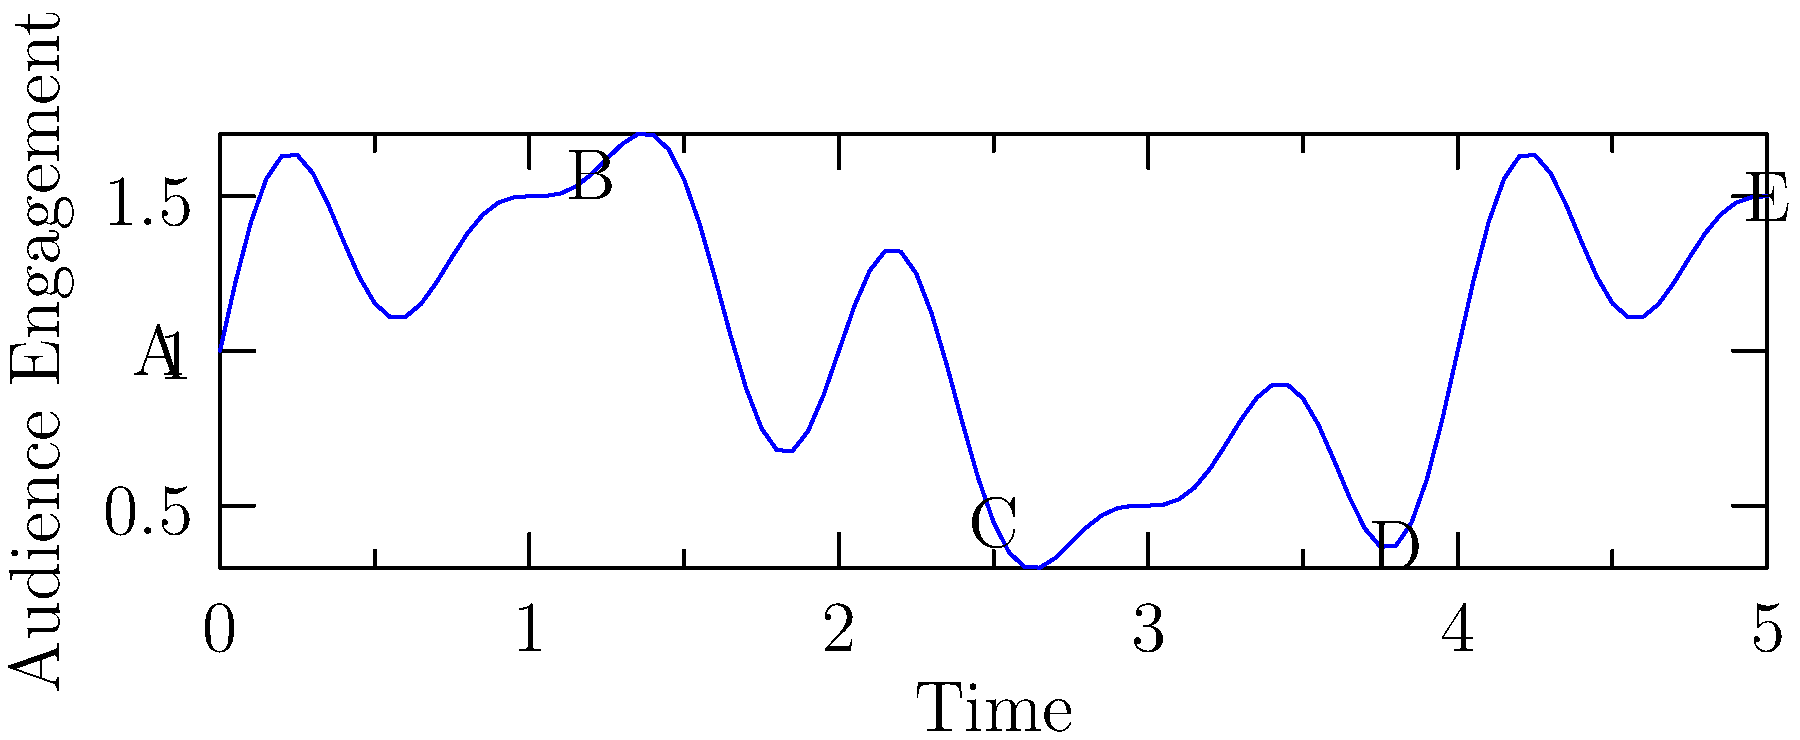In the story arc progression shown above, which point represents the climax that would likely resonate most strongly with both religious and secular audiences in a film that appeals to both demographics? To determine the climax that would resonate with both religious and secular audiences, we need to analyze the story arc progression:

1. Point A: This represents the beginning of the story, typically setting up the characters and conflict.

2. Point B: This is the first significant peak, possibly representing an early challenge or revelation that engages both audiences.

3. Point C: This is the highest peak in the graph, indicating the most intense moment of audience engagement. This would likely be the climax of the film, where:
   - For religious audiences: It might represent a moment of profound spiritual significance or divine intervention.
   - For secular audiences: It could be the resolution of the main conflict or a moment of human triumph.

4. Point D: This is a secondary peak, possibly representing a resolution or aftermath that ties together themes for both audience types.

5. Point E: This is the endpoint of the story, likely providing closure for all viewers.

Given that Point C is the highest peak and occurs at a central point in the story, it is the most likely to represent the climax that would resonate strongly with both religious and secular audiences. This moment would need to be crafted carefully to have universal appeal while still maintaining depth for both demographics.
Answer: Point C 